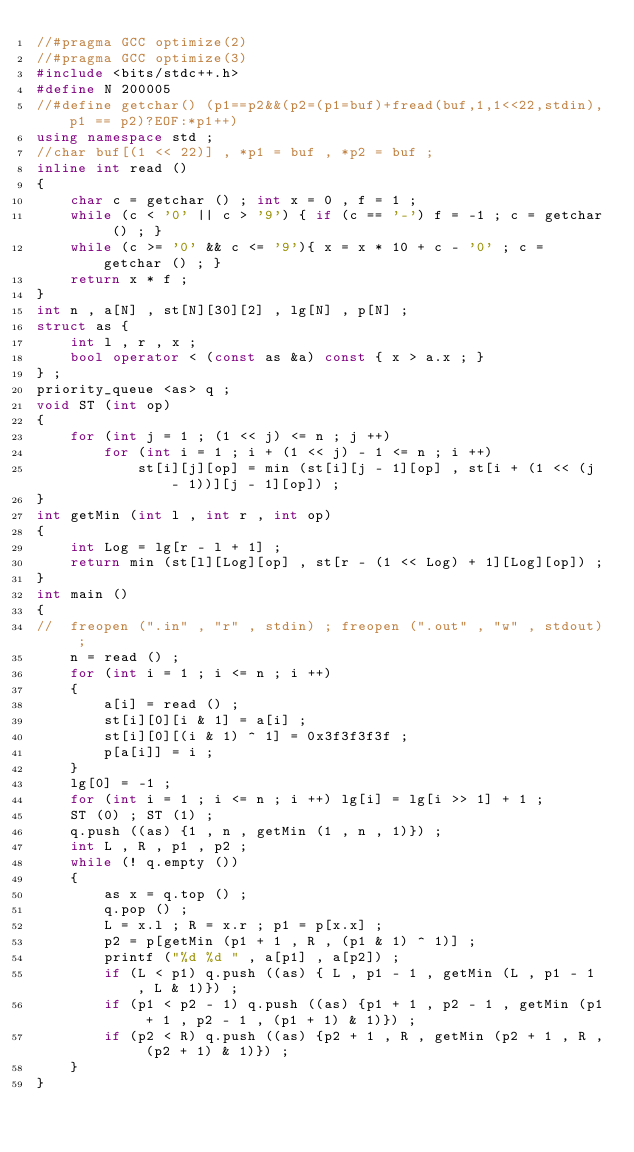<code> <loc_0><loc_0><loc_500><loc_500><_C++_>//#pragma GCC optimize(2)
//#pragma GCC optimize(3)
#include <bits/stdc++.h>
#define N 200005
//#define getchar() (p1==p2&&(p2=(p1=buf)+fread(buf,1,1<<22,stdin),p1 == p2)?EOF:*p1++)
using namespace std ;
//char buf[(1 << 22)] , *p1 = buf , *p2 = buf ;
inline int read ()
{
    char c = getchar () ; int x = 0 , f = 1 ;
    while (c < '0' || c > '9') { if (c == '-') f = -1 ; c = getchar () ; }
    while (c >= '0' && c <= '9'){ x = x * 10 + c - '0' ; c = getchar () ; }
    return x * f ;
}
int n , a[N] , st[N][30][2] , lg[N] , p[N] ;
struct as {
	int l , r , x ;
	bool operator < (const as &a) const { x > a.x ; }
} ;
priority_queue <as> q ;
void ST (int op)
{
	for (int j = 1 ; (1 << j) <= n ; j ++)
		for (int i = 1 ; i + (1 << j) - 1 <= n ; i ++)
			st[i][j][op] = min (st[i][j - 1][op] , st[i + (1 << (j - 1))][j - 1][op]) ;
}
int getMin (int l , int r , int op)
{
	int Log = lg[r - l + 1] ;
	return min (st[l][Log][op] , st[r - (1 << Log) + 1][Log][op]) ;
}
int main ()
{
//	freopen (".in" , "r" , stdin) ; freopen (".out" , "w" , stdout) ;
	n = read () ;
	for (int i = 1 ; i <= n ; i ++)
	{
		a[i] = read () ;
		st[i][0][i & 1] = a[i] ;
		st[i][0][(i & 1) ^ 1] = 0x3f3f3f3f ;
		p[a[i]] = i ;
	}
	lg[0] = -1 ;
	for (int i = 1 ; i <= n ; i ++) lg[i] = lg[i >> 1] + 1 ;
	ST (0) ; ST (1) ;
	q.push ((as) {1 , n , getMin (1 , n , 1)}) ;
	int L , R , p1 , p2 ;
	while (! q.empty ())
	{
		as x = q.top () ;
		q.pop () ;
		L = x.l ; R = x.r ; p1 = p[x.x] ;
		p2 = p[getMin (p1 + 1 , R , (p1 & 1) ^ 1)] ;
		printf ("%d %d " , a[p1] , a[p2]) ;
		if (L < p1) q.push ((as) { L , p1 - 1 , getMin (L , p1 - 1 , L & 1)}) ;
		if (p1 < p2 - 1) q.push ((as) {p1 + 1 , p2 - 1 , getMin (p1 + 1 , p2 - 1 , (p1 + 1) & 1)}) ;
		if (p2 < R) q.push ((as) {p2 + 1 , R , getMin (p2 + 1 , R , (p2 + 1) & 1)}) ; 
	}	
}
</code> 